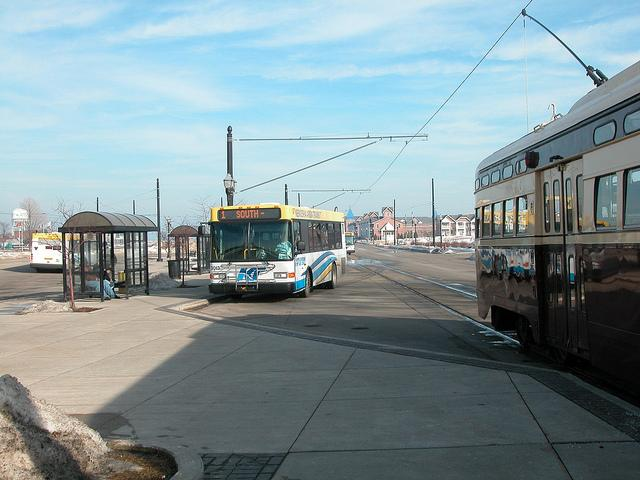What is the overhead wire for? Please explain your reasoning. power streetcars. Thick wires extend across the street in a town. 